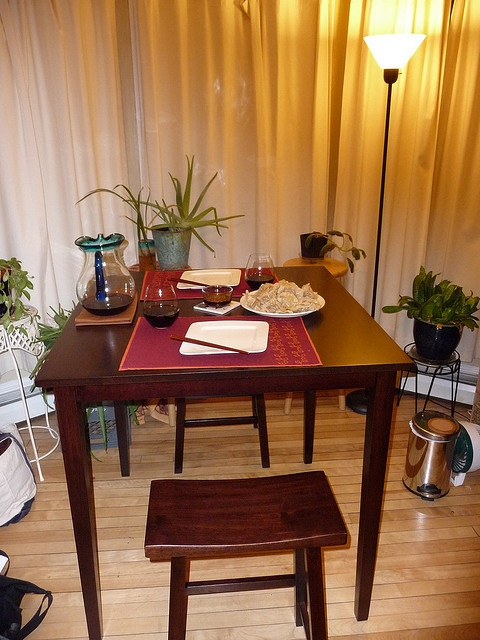Describe the objects in this image and their specific colors. I can see dining table in gray, black, maroon, and brown tones, chair in gray, maroon, black, and tan tones, potted plant in gray, tan, and olive tones, potted plant in gray, black, and olive tones, and chair in gray, black, brown, and maroon tones in this image. 